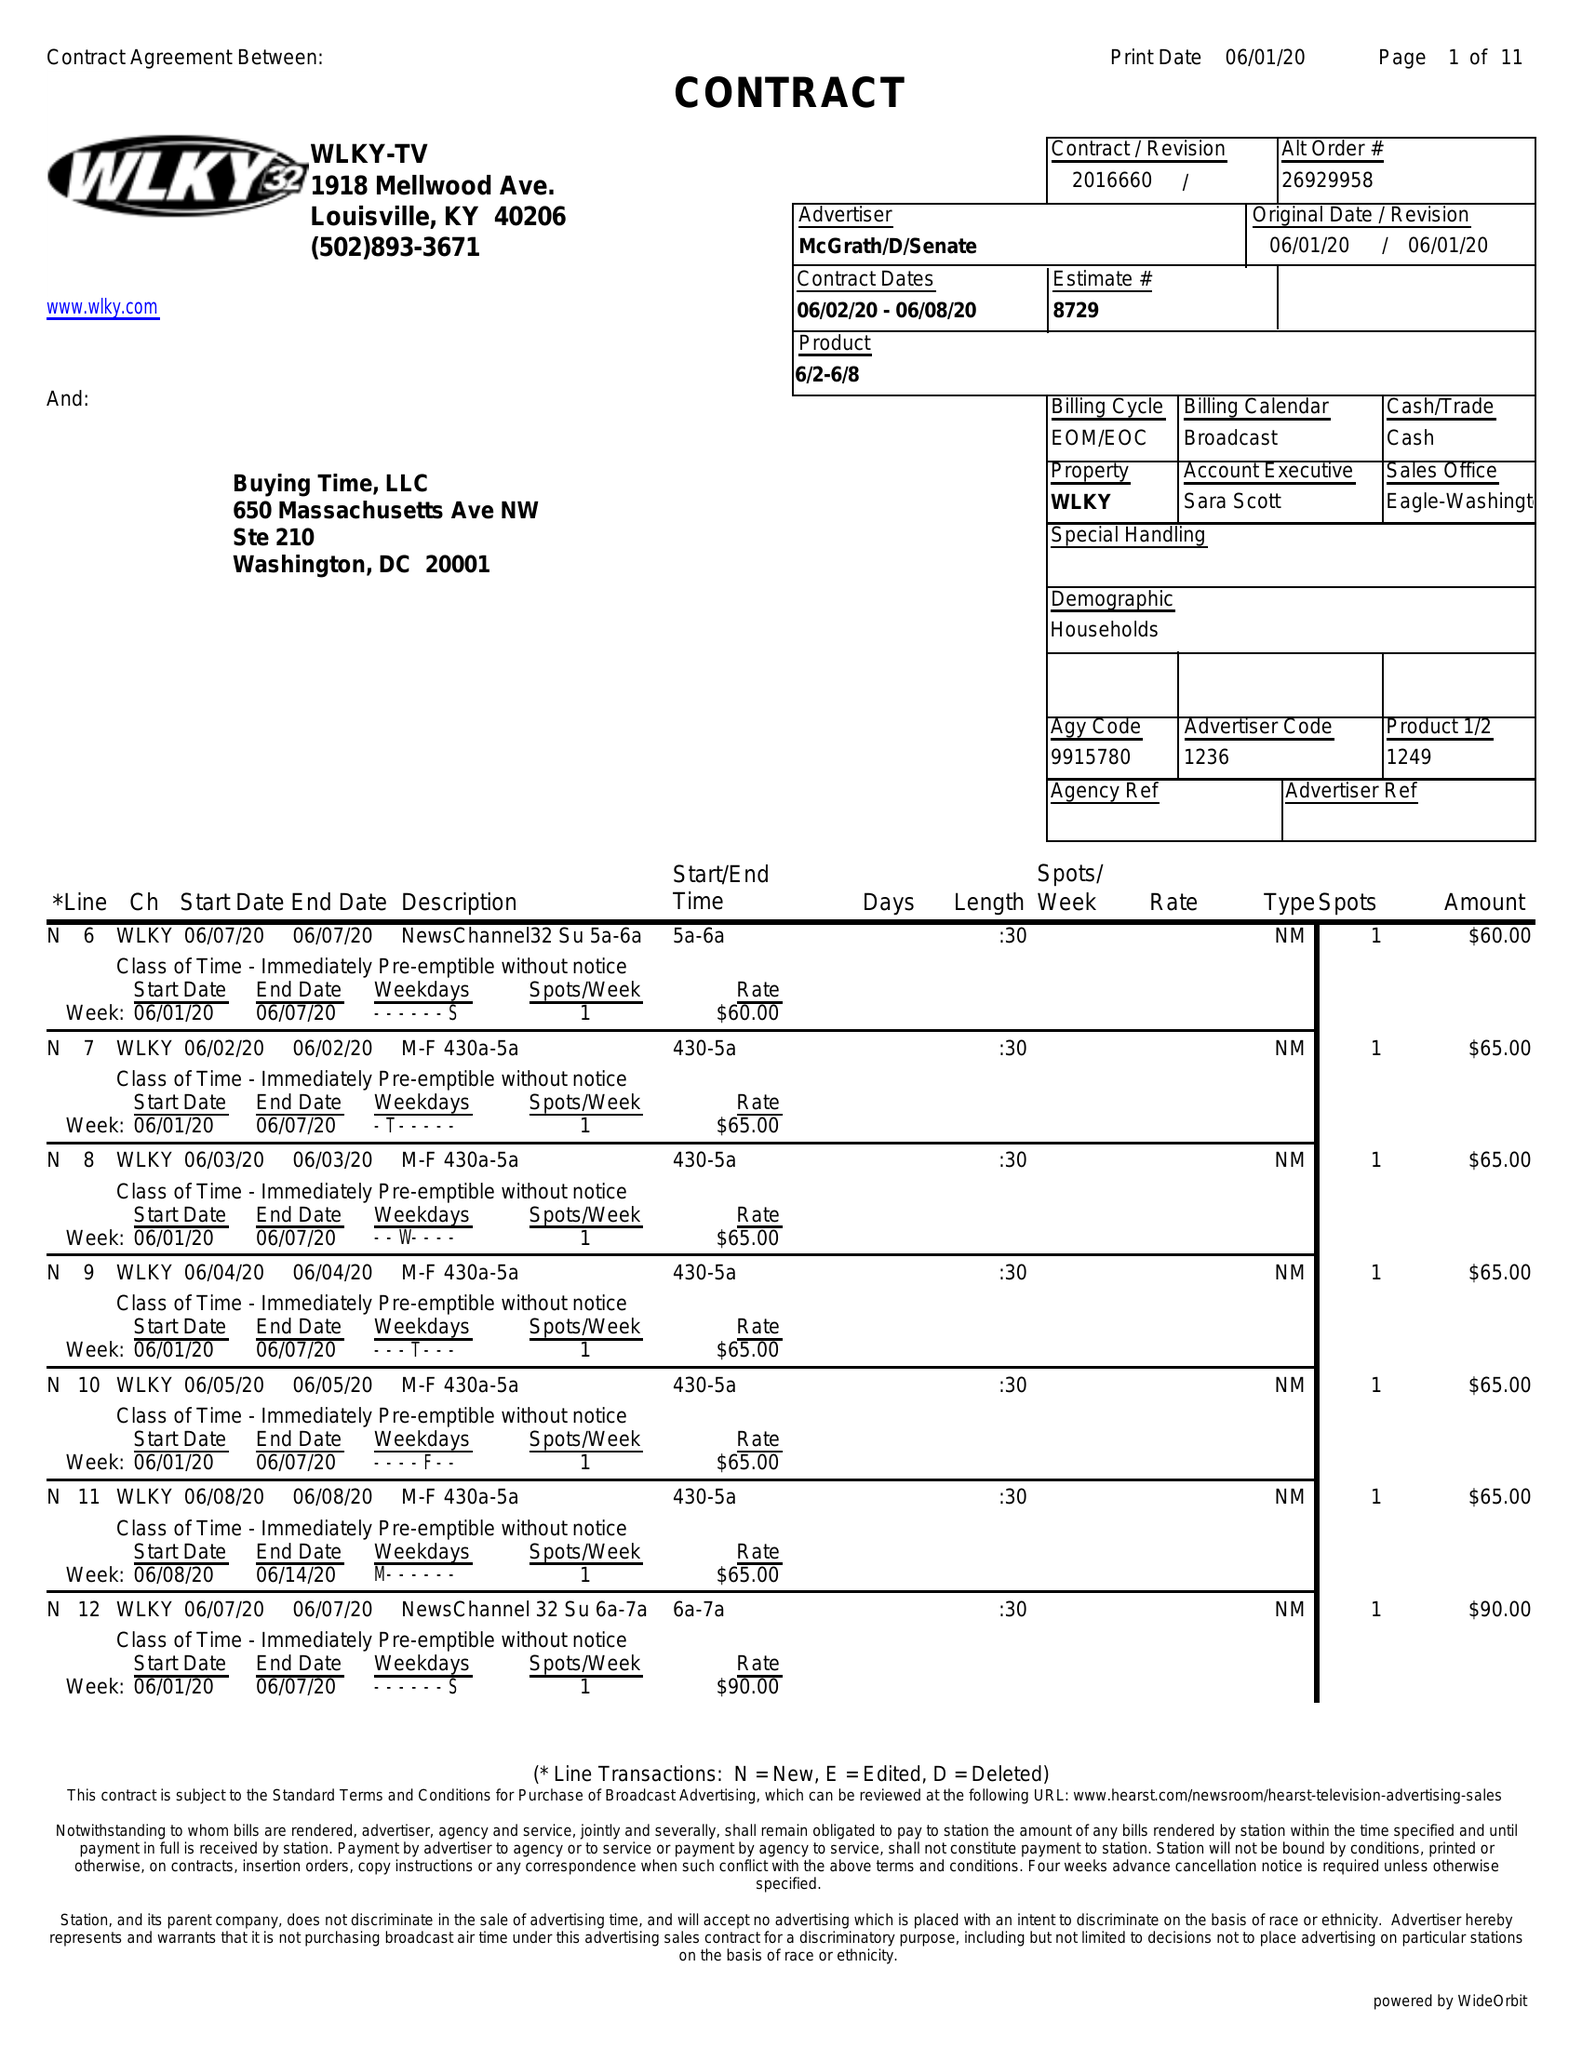What is the value for the contract_num?
Answer the question using a single word or phrase. 2016660 